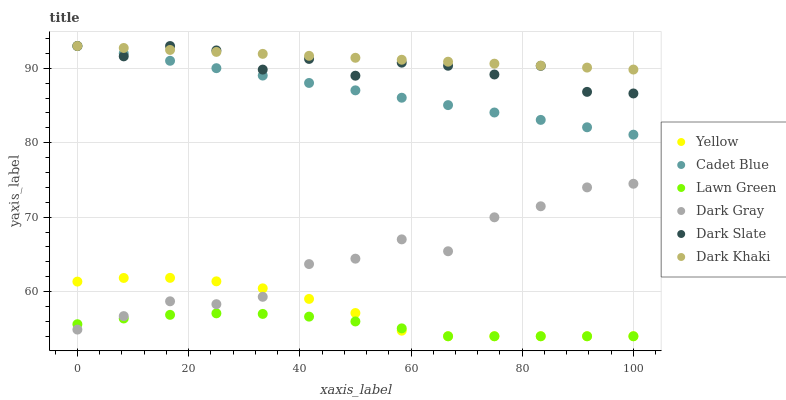Does Lawn Green have the minimum area under the curve?
Answer yes or no. Yes. Does Dark Khaki have the maximum area under the curve?
Answer yes or no. Yes. Does Cadet Blue have the minimum area under the curve?
Answer yes or no. No. Does Cadet Blue have the maximum area under the curve?
Answer yes or no. No. Is Dark Khaki the smoothest?
Answer yes or no. Yes. Is Dark Slate the roughest?
Answer yes or no. Yes. Is Cadet Blue the smoothest?
Answer yes or no. No. Is Cadet Blue the roughest?
Answer yes or no. No. Does Lawn Green have the lowest value?
Answer yes or no. Yes. Does Cadet Blue have the lowest value?
Answer yes or no. No. Does Dark Khaki have the highest value?
Answer yes or no. Yes. Does Yellow have the highest value?
Answer yes or no. No. Is Dark Gray less than Dark Khaki?
Answer yes or no. Yes. Is Dark Slate greater than Dark Gray?
Answer yes or no. Yes. Does Dark Gray intersect Yellow?
Answer yes or no. Yes. Is Dark Gray less than Yellow?
Answer yes or no. No. Is Dark Gray greater than Yellow?
Answer yes or no. No. Does Dark Gray intersect Dark Khaki?
Answer yes or no. No. 